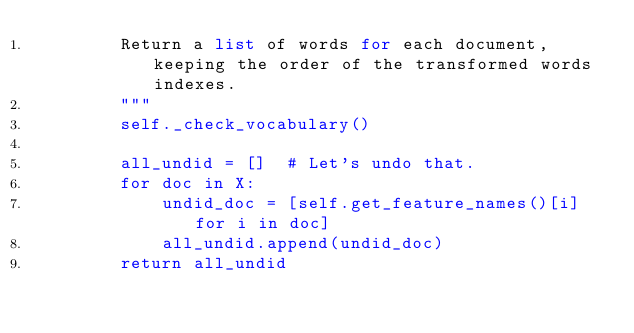<code> <loc_0><loc_0><loc_500><loc_500><_Python_>        Return a list of words for each document, keeping the order of the transformed words indexes.
        """
        self._check_vocabulary()

        all_undid = []  # Let's undo that.
        for doc in X:
            undid_doc = [self.get_feature_names()[i] for i in doc]
            all_undid.append(undid_doc)
        return all_undid
</code> 